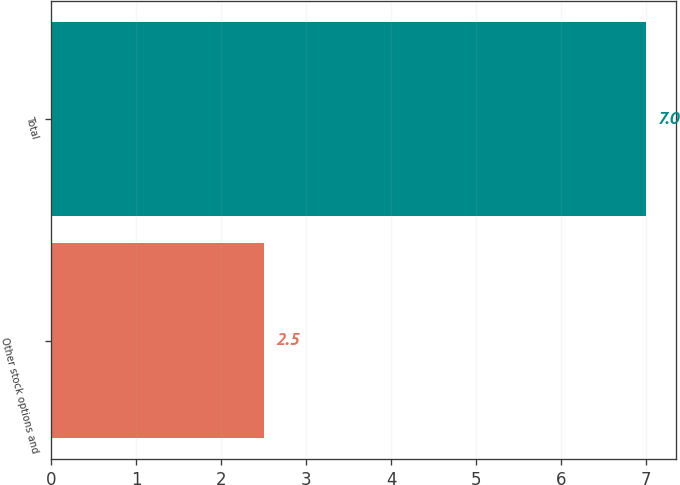Convert chart to OTSL. <chart><loc_0><loc_0><loc_500><loc_500><bar_chart><fcel>Other stock options and<fcel>Total<nl><fcel>2.5<fcel>7<nl></chart> 